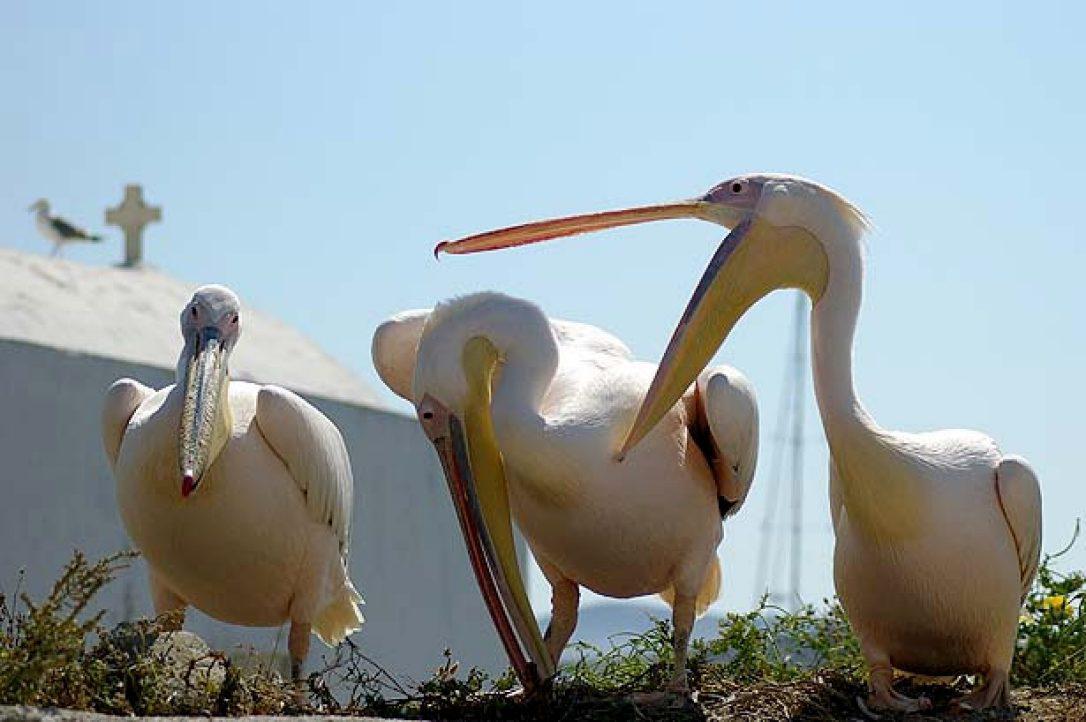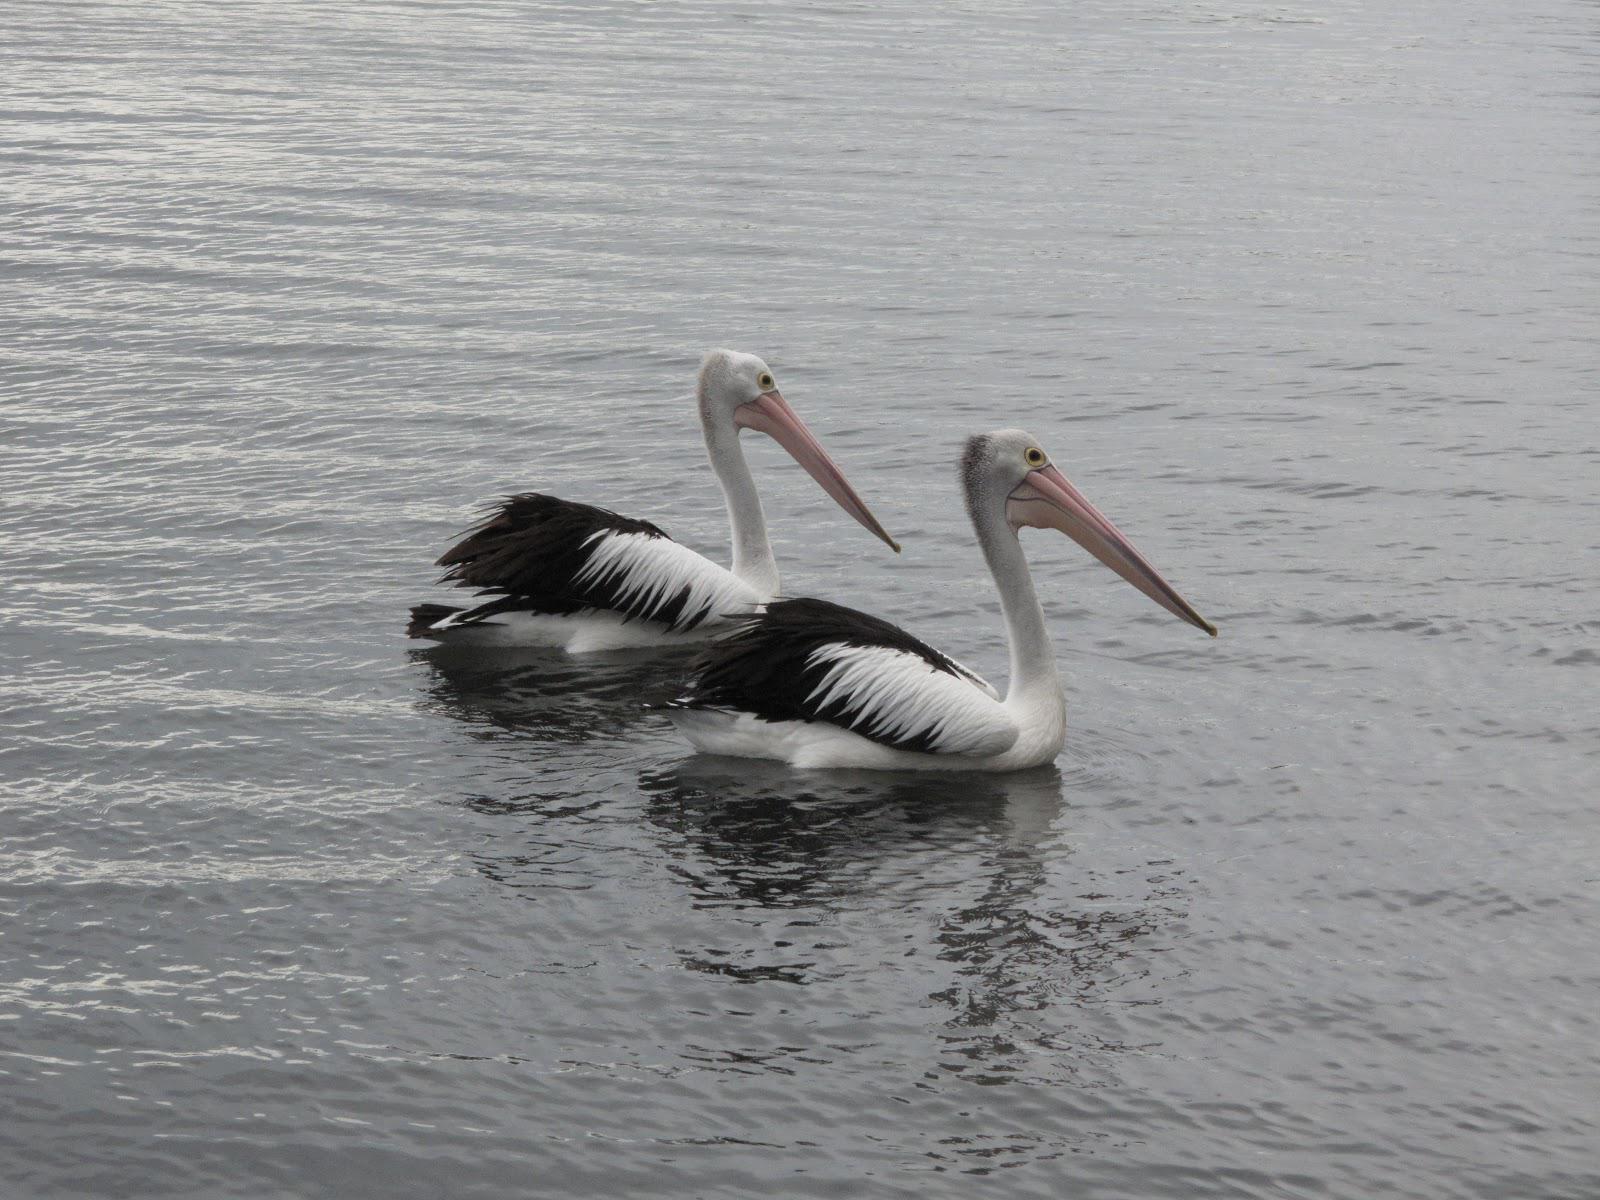The first image is the image on the left, the second image is the image on the right. Examine the images to the left and right. Is the description "Three birds in the image on the left are standing on a manmade object near the water." accurate? Answer yes or no. No. The first image is the image on the left, the second image is the image on the right. Examine the images to the left and right. Is the description "An image shows at least two pelicans standing on a flat manmade platform over the water." accurate? Answer yes or no. No. 